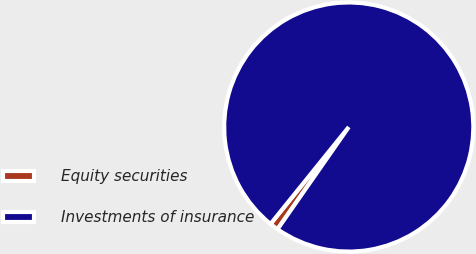<chart> <loc_0><loc_0><loc_500><loc_500><pie_chart><fcel>Equity securities<fcel>Investments of insurance<nl><fcel>1.12%<fcel>98.88%<nl></chart> 